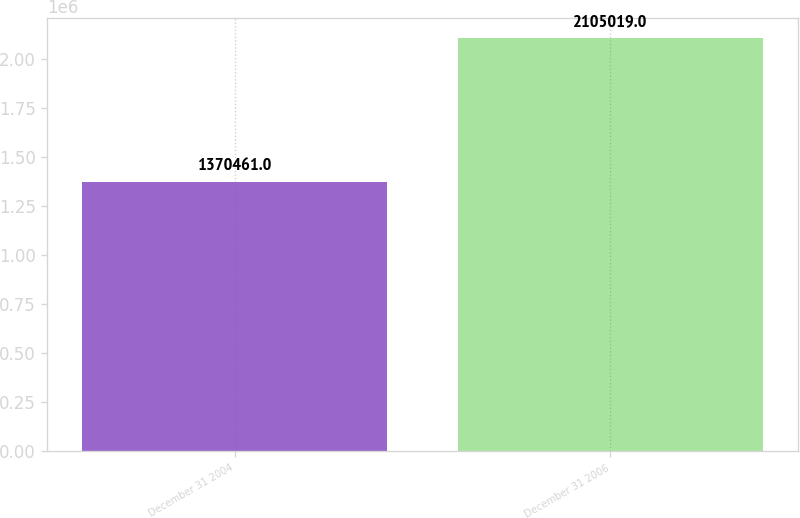Convert chart. <chart><loc_0><loc_0><loc_500><loc_500><bar_chart><fcel>December 31 2004<fcel>December 31 2006<nl><fcel>1.37046e+06<fcel>2.10502e+06<nl></chart> 